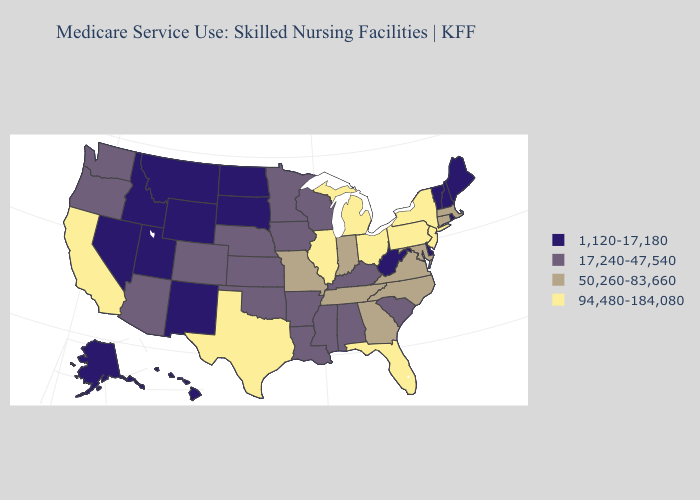What is the value of Montana?
Concise answer only. 1,120-17,180. Name the states that have a value in the range 50,260-83,660?
Write a very short answer. Connecticut, Georgia, Indiana, Maryland, Massachusetts, Missouri, North Carolina, Tennessee, Virginia. What is the lowest value in states that border Kansas?
Quick response, please. 17,240-47,540. What is the value of Texas?
Answer briefly. 94,480-184,080. Which states have the highest value in the USA?
Be succinct. California, Florida, Illinois, Michigan, New Jersey, New York, Ohio, Pennsylvania, Texas. Name the states that have a value in the range 1,120-17,180?
Answer briefly. Alaska, Delaware, Hawaii, Idaho, Maine, Montana, Nevada, New Hampshire, New Mexico, North Dakota, Rhode Island, South Dakota, Utah, Vermont, West Virginia, Wyoming. Name the states that have a value in the range 50,260-83,660?
Give a very brief answer. Connecticut, Georgia, Indiana, Maryland, Massachusetts, Missouri, North Carolina, Tennessee, Virginia. Does Arizona have a higher value than South Dakota?
Be succinct. Yes. What is the value of New Mexico?
Quick response, please. 1,120-17,180. Name the states that have a value in the range 94,480-184,080?
Keep it brief. California, Florida, Illinois, Michigan, New Jersey, New York, Ohio, Pennsylvania, Texas. Is the legend a continuous bar?
Give a very brief answer. No. What is the value of Kansas?
Keep it brief. 17,240-47,540. Which states have the lowest value in the Northeast?
Concise answer only. Maine, New Hampshire, Rhode Island, Vermont. Name the states that have a value in the range 1,120-17,180?
Answer briefly. Alaska, Delaware, Hawaii, Idaho, Maine, Montana, Nevada, New Hampshire, New Mexico, North Dakota, Rhode Island, South Dakota, Utah, Vermont, West Virginia, Wyoming. Does the first symbol in the legend represent the smallest category?
Concise answer only. Yes. 